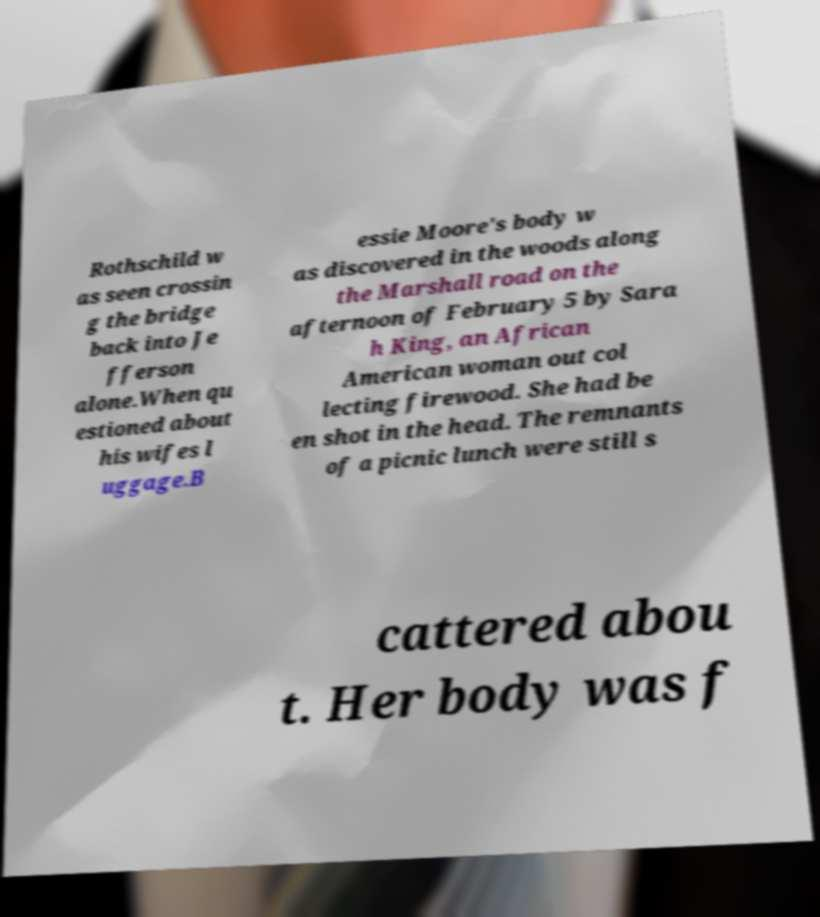I need the written content from this picture converted into text. Can you do that? Rothschild w as seen crossin g the bridge back into Je fferson alone.When qu estioned about his wifes l uggage.B essie Moore's body w as discovered in the woods along the Marshall road on the afternoon of February 5 by Sara h King, an African American woman out col lecting firewood. She had be en shot in the head. The remnants of a picnic lunch were still s cattered abou t. Her body was f 